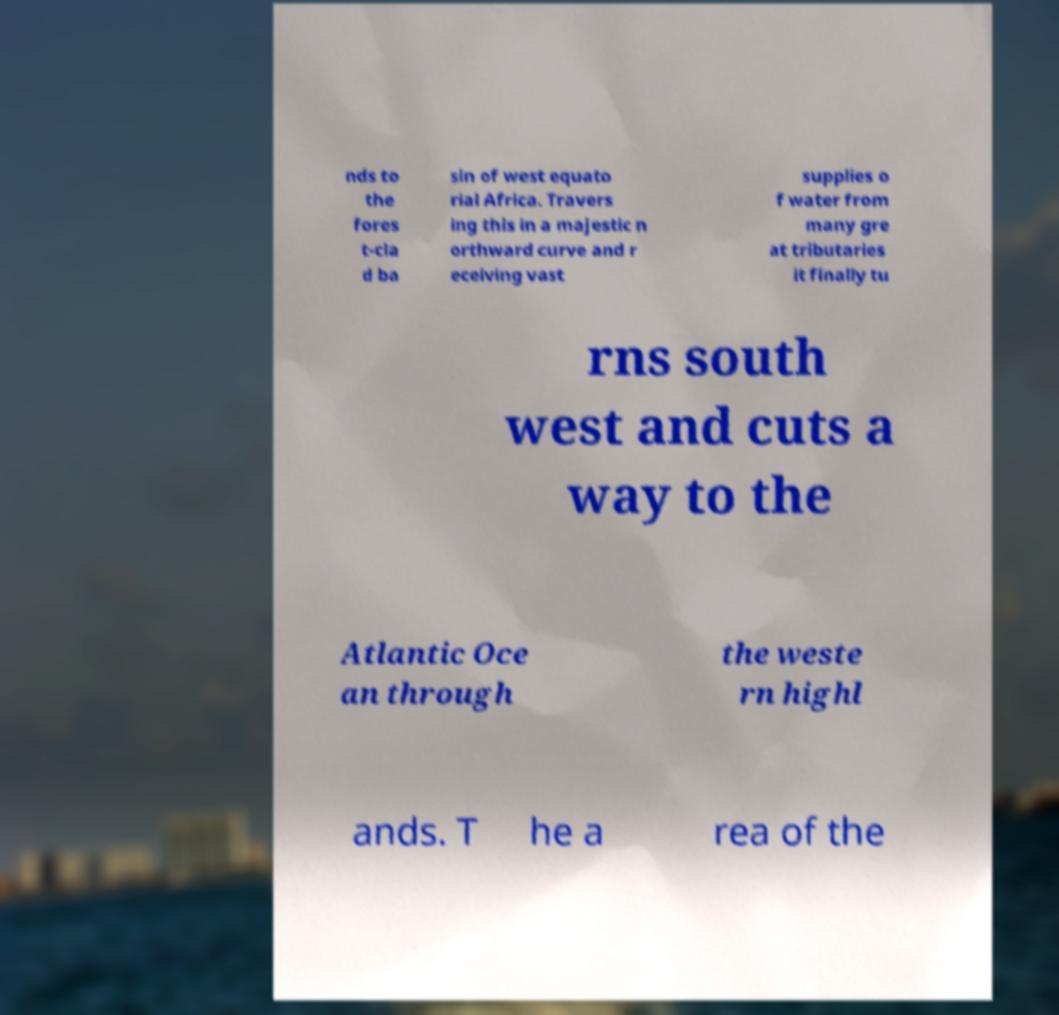Please read and relay the text visible in this image. What does it say? nds to the fores t-cla d ba sin of west equato rial Africa. Travers ing this in a majestic n orthward curve and r eceiving vast supplies o f water from many gre at tributaries it finally tu rns south west and cuts a way to the Atlantic Oce an through the weste rn highl ands. T he a rea of the 